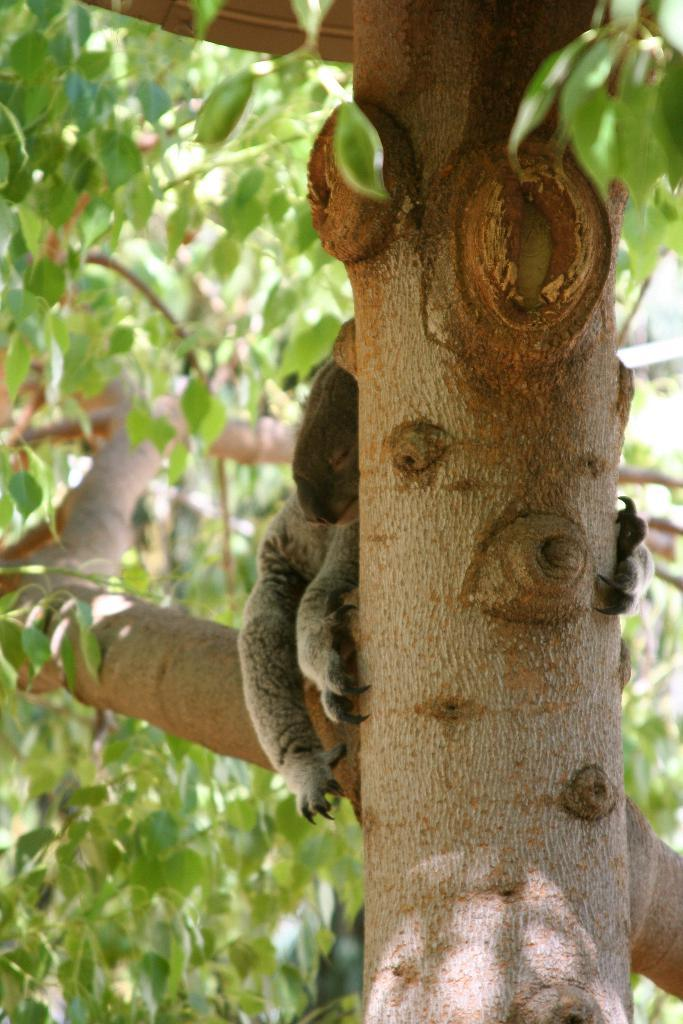What type of plant can be seen in the image? There is a tree in the image. What colors are present on the tree? The tree has brown and green colors. What type of living creature is in the image? There is an animal in the image. What colors are present on the animal? The animal has grey and brown colors. What is the animal doing in the image? The animal is laying on the tree. What type of guitar is the parent playing in the image? There is no guitar or parent present in the image. 